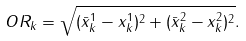Convert formula to latex. <formula><loc_0><loc_0><loc_500><loc_500>O R _ { k } = \sqrt { ( \bar { x } ^ { 1 } _ { k } - x ^ { 1 } _ { k } ) ^ { 2 } + ( \bar { x } ^ { 2 } _ { k } - x ^ { 2 } _ { k } ) ^ { 2 } } .</formula> 